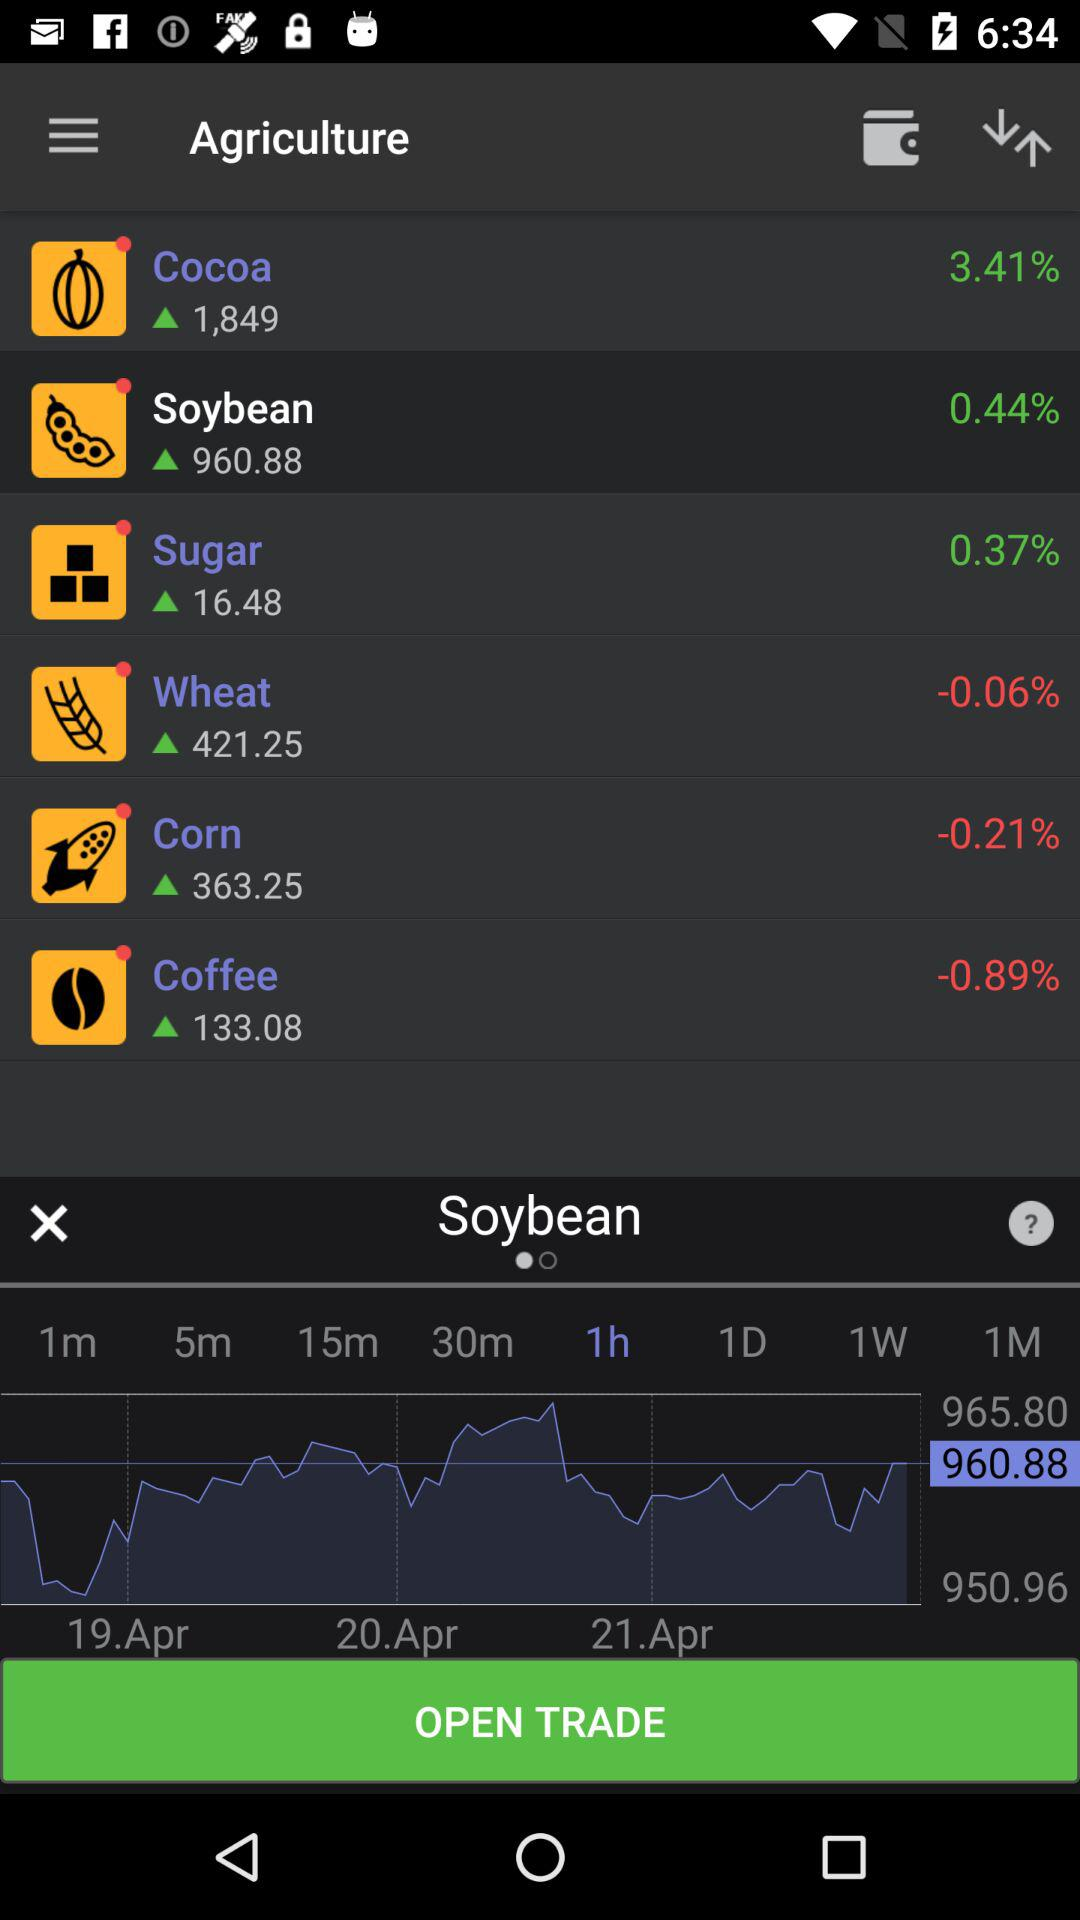When does trade open?
When the provided information is insufficient, respond with <no answer>. <no answer> 